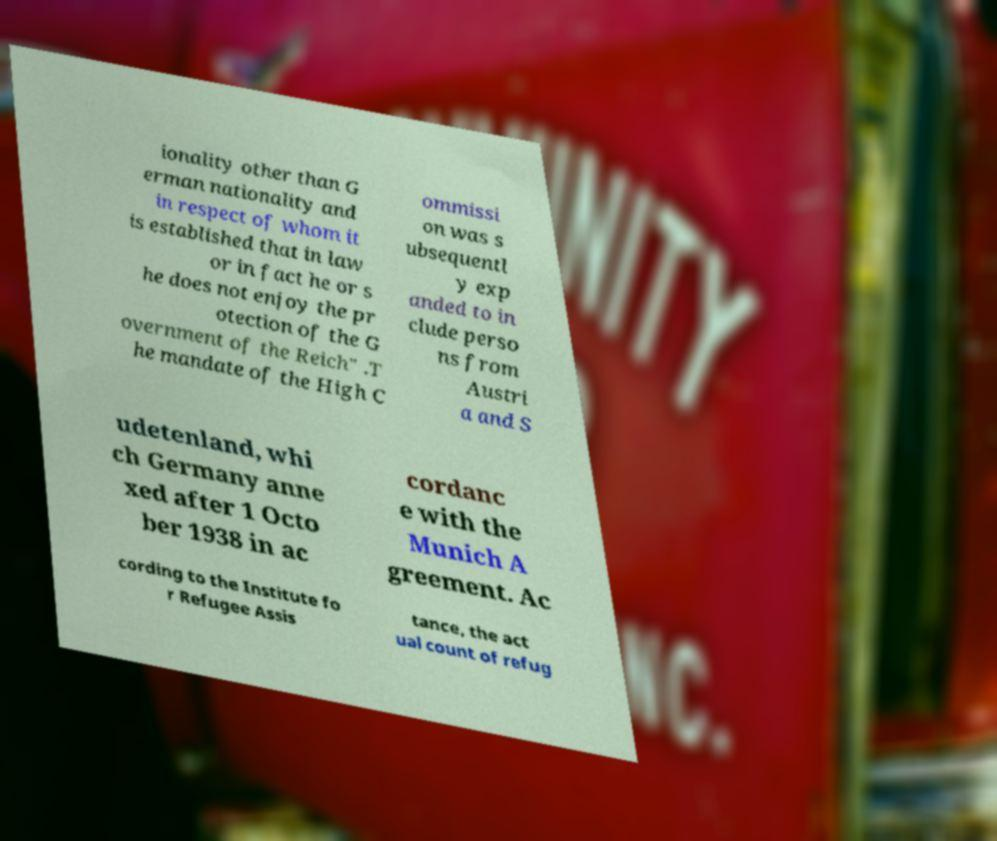There's text embedded in this image that I need extracted. Can you transcribe it verbatim? ionality other than G erman nationality and in respect of whom it is established that in law or in fact he or s he does not enjoy the pr otection of the G overnment of the Reich" .T he mandate of the High C ommissi on was s ubsequentl y exp anded to in clude perso ns from Austri a and S udetenland, whi ch Germany anne xed after 1 Octo ber 1938 in ac cordanc e with the Munich A greement. Ac cording to the Institute fo r Refugee Assis tance, the act ual count of refug 